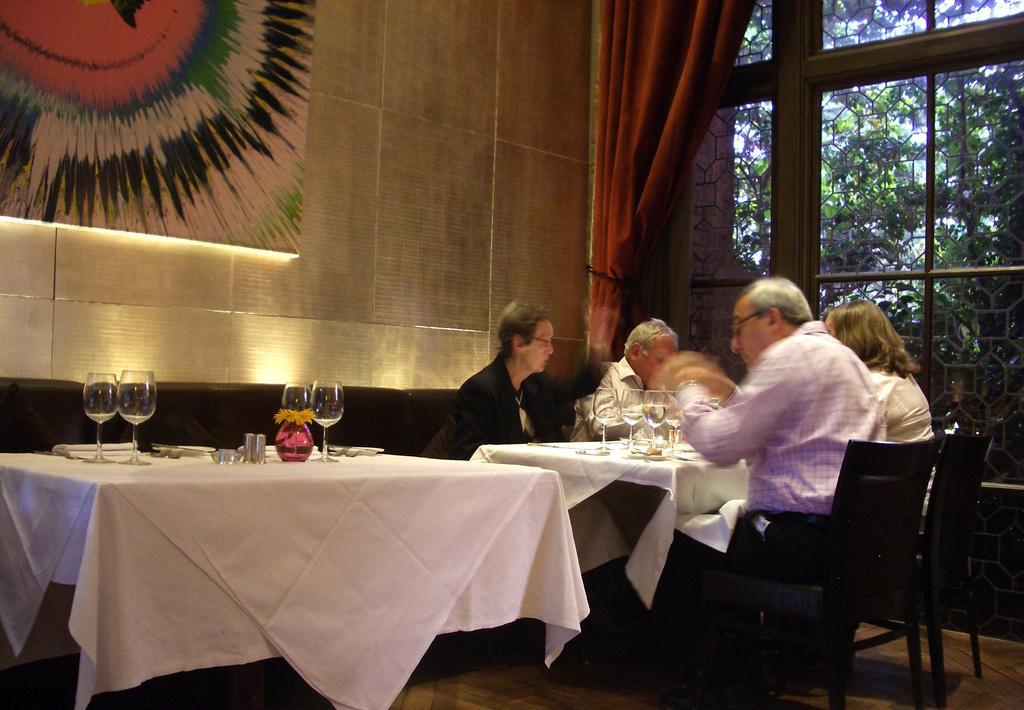Can you describe this image briefly? As we can see in the image, there is a wall, window, curtain, tables and few people sitting on chairs. On table there are glasses and pillows. 